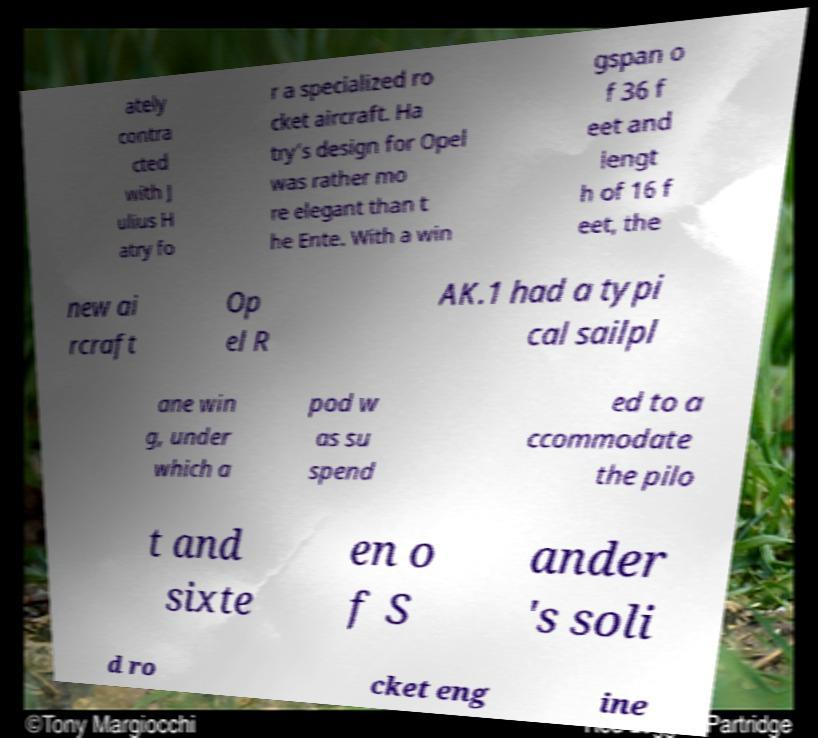Can you read and provide the text displayed in the image?This photo seems to have some interesting text. Can you extract and type it out for me? ately contra cted with J ulius H atry fo r a specialized ro cket aircraft. Ha try’s design for Opel was rather mo re elegant than t he Ente. With a win gspan o f 36 f eet and lengt h of 16 f eet, the new ai rcraft Op el R AK.1 had a typi cal sailpl ane win g, under which a pod w as su spend ed to a ccommodate the pilo t and sixte en o f S ander 's soli d ro cket eng ine 